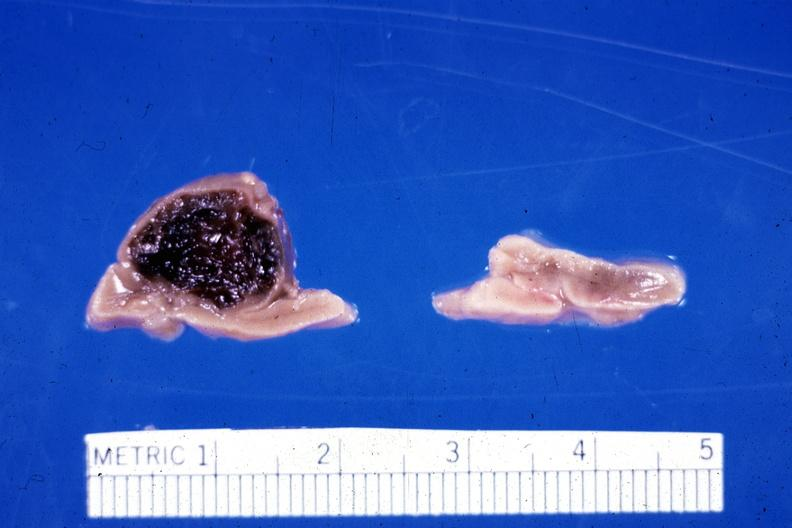s newborn cord around neck present?
Answer the question using a single word or phrase. No 